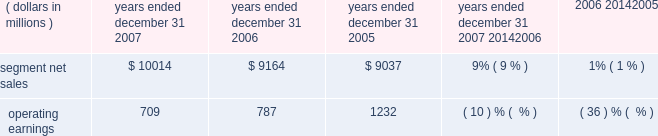Unit shipments increased 49% ( 49 % ) to 217.4 million units in 2006 , compared to 146.0 million units in 2005 .
The overall increase was driven by increased unit shipments of products for gsm , cdma and 3g technologies , partially offset by decreased unit shipments of products for iden technology .
For the full year 2006 , unit shipments by the segment increased in all regions .
Due to the segment 2019s increase in unit shipments outpacing overall growth in the worldwide handset market , which grew approximately 20% ( 20 % ) in 2006 , the segment believes that it expanded its global handset market share to an estimated 22% ( 22 % ) for the full year 2006 .
In 2006 , asp decreased approximately 11% ( 11 % ) compared to 2005 .
The overall decrease in asp was driven primarily by changes in the geographic and product-tier mix of sales .
By comparison , asp decreased approximately 10% ( 10 % ) in 2005 and increased approximately 15% ( 15 % ) in 2004 .
Asp is impacted by numerous factors , including product mix , market conditions and competitive product offerings , and asp trends often vary over time .
In 2006 , the largest of the segment 2019s end customers ( including sales through distributors ) were china mobile , verizon , sprint nextel , cingular , and t-mobile .
These five largest customers accounted for approximately 39% ( 39 % ) of the segment 2019s net sales in 2006 .
Besides selling directly to carriers and operators , the segment also sold products through a variety of third-party distributors and retailers , which accounted for approximately 38% ( 38 % ) of the segment 2019s net sales .
The largest of these distributors was brightstar corporation .
Although the u.s .
Market continued to be the segment 2019s largest individual market , many of our customers , and more than 65% ( 65 % ) of the segment 2019s 2006 net sales , were outside the u.s .
The largest of these international markets were china , brazil , the united kingdom and mexico .
Home and networks mobility segment the home and networks mobility segment designs , manufactures , sells , installs and services : ( i ) digital video , internet protocol ( 201cip 201d ) video and broadcast network interactive set-tops ( 201cdigital entertainment devices 201d ) , end-to- end video delivery solutions , broadband access infrastructure systems , and associated data and voice customer premise equipment ( 201cbroadband gateways 201d ) to cable television and telecom service providers ( collectively , referred to as the 201chome business 201d ) , and ( ii ) wireless access systems ( 201cwireless networks 201d ) , including cellular infrastructure systems and wireless broadband systems , to wireless service providers .
In 2007 , the segment 2019s net sales represented 27% ( 27 % ) of the company 2019s consolidated net sales , compared to 21% ( 21 % ) in 2006 and 26% ( 26 % ) in 2005 .
( dollars in millions ) 2007 2006 2005 2007 20142006 2006 20142005 years ended december 31 percent change .
Segment results 20142007 compared to 2006 in 2007 , the segment 2019s net sales increased 9% ( 9 % ) to $ 10.0 billion , compared to $ 9.2 billion in 2006 .
The 9% ( 9 % ) increase in net sales reflects a 27% ( 27 % ) increase in net sales in the home business , partially offset by a 1% ( 1 % ) decrease in net sales of wireless networks .
Net sales of digital entertainment devices increased approximately 43% ( 43 % ) , reflecting increased demand for digital set-tops , including hd/dvr set-tops and ip set-tops , partially offset by a decline in asp due to a product mix shift towards all-digital set-tops .
Unit shipments of digital entertainment devices increased 51% ( 51 % ) to 15.2 million units .
Net sales of broadband gateways increased approximately 6% ( 6 % ) , primarily due to higher net sales of data modems , driven by net sales from the netopia business acquired in february 2007 .
Net sales of wireless networks decreased 1% ( 1 % ) , primarily driven by lower net sales of iden and cdma infrastructure equipment , partially offset by higher net sales of gsm infrastructure equipment , despite competitive pricing pressure .
On a geographic basis , the 9% ( 9 % ) increase in net sales reflects higher net sales in all geographic regions .
The increase in net sales in north america was driven primarily by higher sales of digital entertainment devices , partially offset by lower net sales of iden and cdma infrastructure equipment .
The increase in net sales in asia was primarily due to higher net sales of gsm infrastructure equipment , partially offset by lower net sales of cdma infrastructure equipment .
The increase in net sales in emea was , primarily due to higher net sales of gsm infrastructure equipment , partially offset by lower demand for iden and cdma infrastructure equipment .
Net sales in north america continue to comprise a significant portion of the segment 2019s business , accounting for 52% ( 52 % ) of the segment 2019s total net sales in 2007 , compared to 56% ( 56 % ) of the segment 2019s total net sales in 2006 .
60 management 2019s discussion and analysis of financial condition and results of operations .
In 2007what was the company 2019s consolidated net sales in millions? 
Computations: (10014 / 27%)
Answer: 37088.88889. 